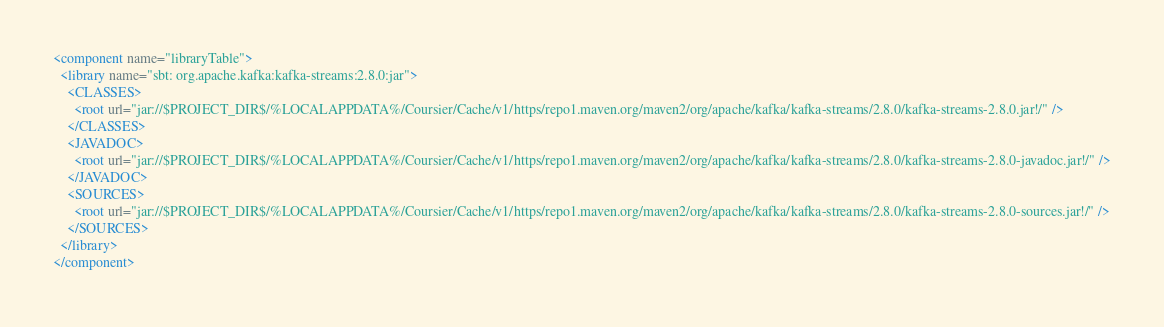<code> <loc_0><loc_0><loc_500><loc_500><_XML_><component name="libraryTable">
  <library name="sbt: org.apache.kafka:kafka-streams:2.8.0:jar">
    <CLASSES>
      <root url="jar://$PROJECT_DIR$/%LOCALAPPDATA%/Coursier/Cache/v1/https/repo1.maven.org/maven2/org/apache/kafka/kafka-streams/2.8.0/kafka-streams-2.8.0.jar!/" />
    </CLASSES>
    <JAVADOC>
      <root url="jar://$PROJECT_DIR$/%LOCALAPPDATA%/Coursier/Cache/v1/https/repo1.maven.org/maven2/org/apache/kafka/kafka-streams/2.8.0/kafka-streams-2.8.0-javadoc.jar!/" />
    </JAVADOC>
    <SOURCES>
      <root url="jar://$PROJECT_DIR$/%LOCALAPPDATA%/Coursier/Cache/v1/https/repo1.maven.org/maven2/org/apache/kafka/kafka-streams/2.8.0/kafka-streams-2.8.0-sources.jar!/" />
    </SOURCES>
  </library>
</component></code> 